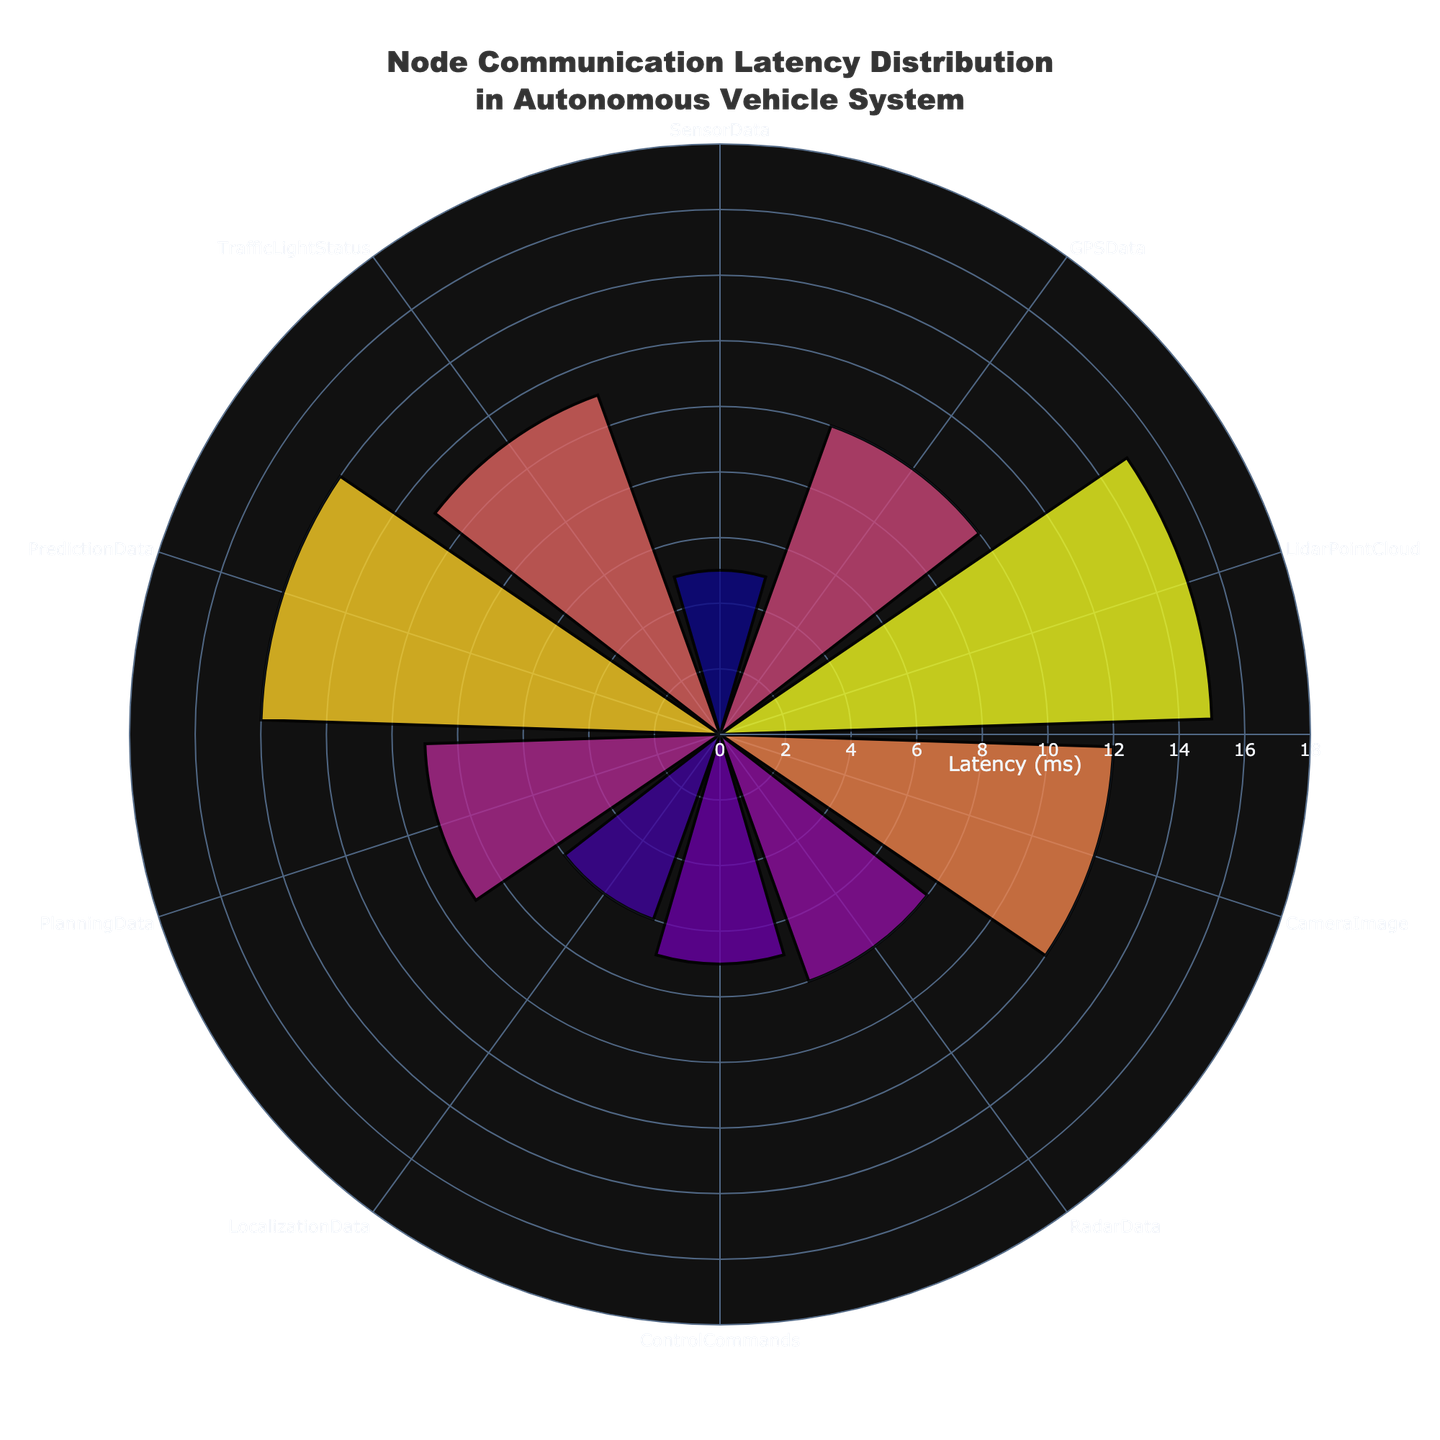What is the title of the figure? The title of the figure is typically displayed prominently at the top and provides an overview of what the chart represents. From the description, we know that the title should reference node communication and latency in an autonomous vehicle system.
Answer: Node Communication Latency Distribution in Autonomous Vehicle System What are the axes of the polar area chart? A polar area chart typically has a radial axis and an angular axis. The radial axis in this case is labeled "Latency (ms)" and the angular axis represents different message types.
Answer: Radial axis: Latency (ms); Angular axis: MessageType Which message type has the highest latency? The highest latency value is the largest segment in the figure. The segment corresponding to "LidarPointCloud" is the largest with a value of 15 ms.
Answer: LidarPointCloud How many message types are represented in the figure? Each distinct segment in the polar area chart represents a different message type. By counting these segments, we see there are a total of 10 message types.
Answer: 10 What is the combined latency of GPSData, CameraImage, and PlanningData? To find the combined latency, sum the individual latency values of GPSData (10 ms), CameraImage (12 ms), and PlanningData (9 ms). Therefore, 10 + 12 + 9 = 31 ms.
Answer: 31 ms Which message type has the lowest latency, and what is its value? The smallest segment on the radial axis represents the lowest latency. For this chart, "SensorData" has the shortest segment with a latency of 5 ms.
Answer: SensorData; 5 ms What is the average latency across all message types? To find the average, sum all latency values and divide by the number of message types. Thus, (5+10+15+12+8+7+6+9+14+11) / 10 = 9.7 ms.
Answer: 9.7 ms Is the latency of PredictionData greater than the latency of TrafficLightStatus? Compare the two segments for PredictionData and TrafficLightStatus. PredictionData has a latency of 14 ms, which is greater than TrafficLightStatus at 11 ms.
Answer: Yes What's the difference in latency between LidarPointCloud and ControlCommands? Subtract the latency of ControlCommands from LidarPointCloud. So, 15 ms - 7 ms = 8 ms.
Answer: 8 ms Among SensorData, GPSData, and LocalizationData, which have less than 10 ms latency? Identify message types with latency less than 10 ms among the given data points. SensorData (5 ms), LocalizationData (6 ms) both have latencies less than 10 ms, while GPSData (10 ms) does not.
Answer: SensorData, LocalizationData 